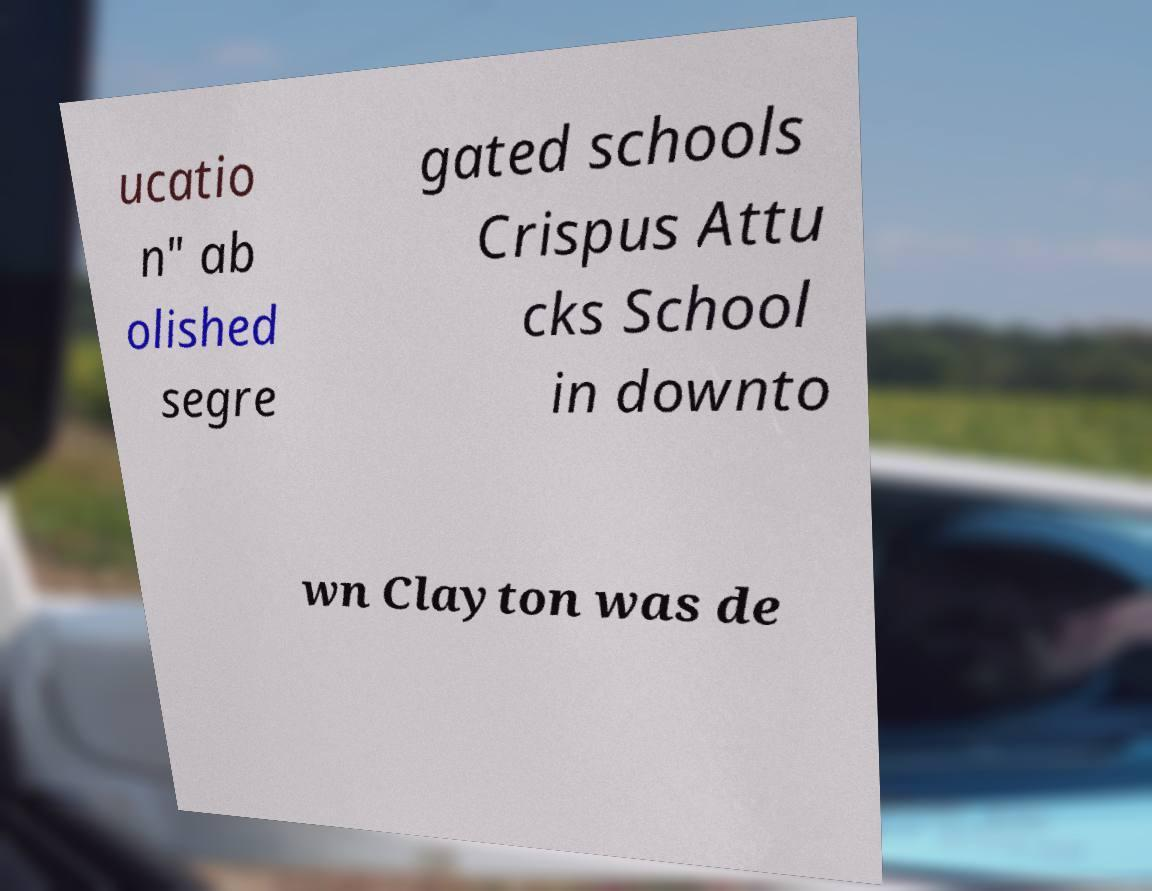Please identify and transcribe the text found in this image. ucatio n" ab olished segre gated schools Crispus Attu cks School in downto wn Clayton was de 